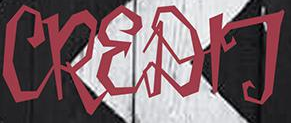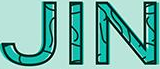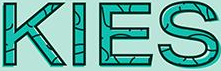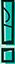Read the text from these images in sequence, separated by a semicolon. CREDIT; JIN; KIES; ! 